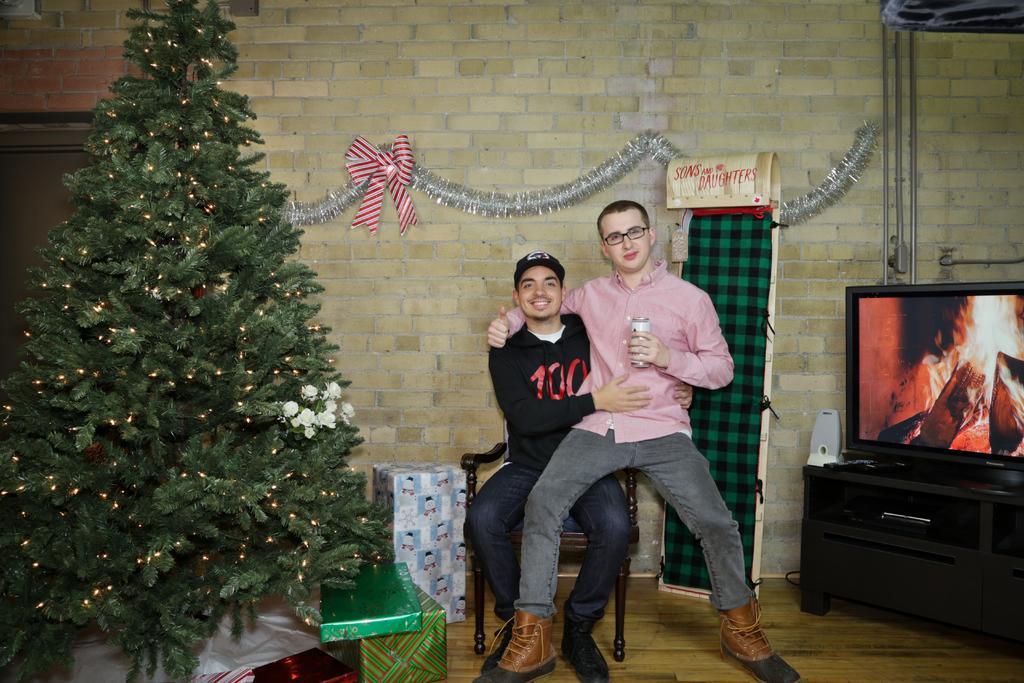How would you summarize this image in a sentence or two? In this image we can see two persons, one of them is holding a soda can, there is a Christmas tree, gifts, there is a TV on the table, there are decorative items, also we can see the wall, and a door. 